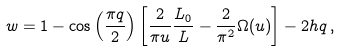Convert formula to latex. <formula><loc_0><loc_0><loc_500><loc_500>w = 1 - \cos { \left ( \frac { \pi q } { 2 } \right ) } \left [ \frac { 2 } { \pi u } \frac { L _ { 0 } } { L } - \frac { 2 } { \pi ^ { 2 } } \Omega ( u ) \right ] - 2 h q \, ,</formula> 